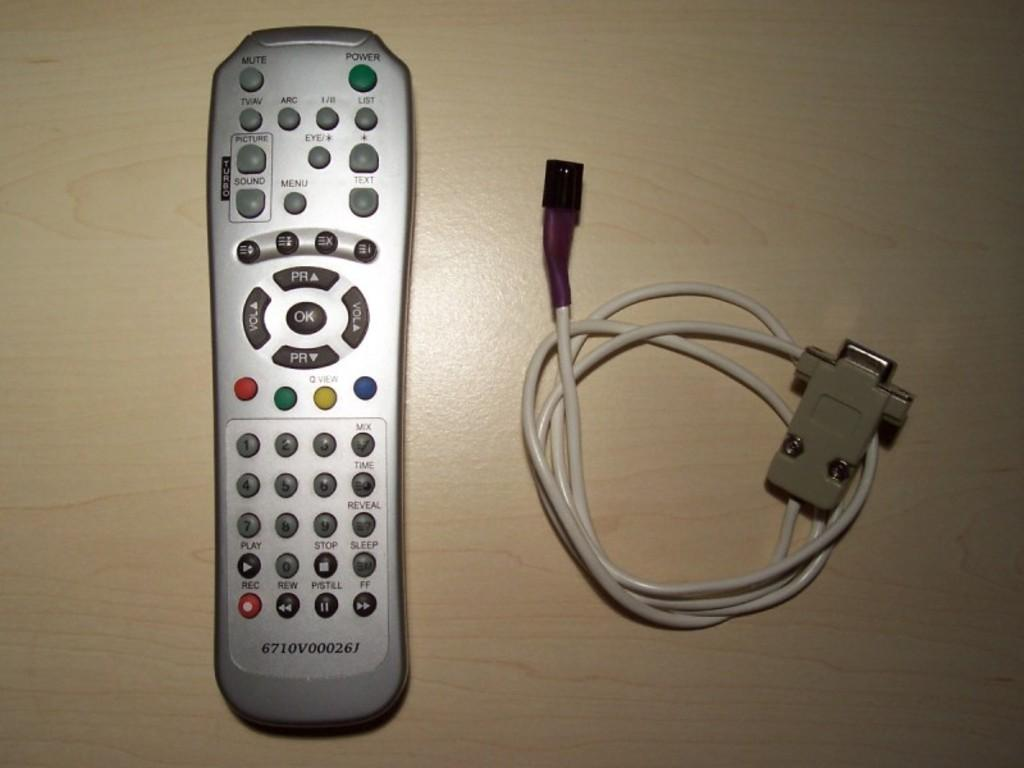Provide a one-sentence caption for the provided image. A cable and adapter sits next to a silver remote with number 6710v000261 at the bottom. 